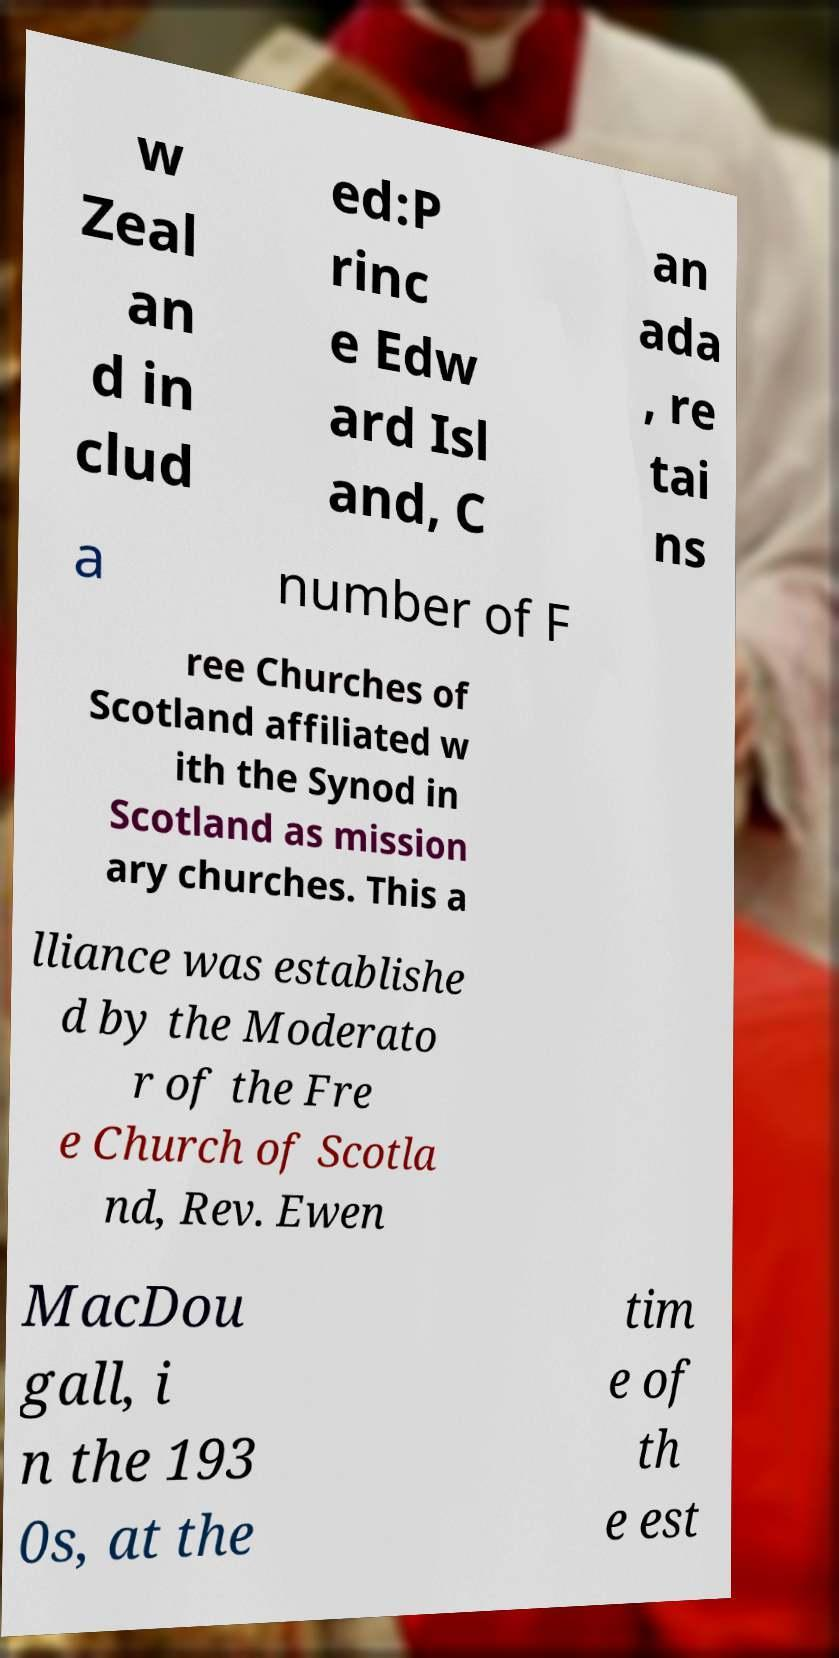Could you extract and type out the text from this image? w Zeal an d in clud ed:P rinc e Edw ard Isl and, C an ada , re tai ns a number of F ree Churches of Scotland affiliated w ith the Synod in Scotland as mission ary churches. This a lliance was establishe d by the Moderato r of the Fre e Church of Scotla nd, Rev. Ewen MacDou gall, i n the 193 0s, at the tim e of th e est 